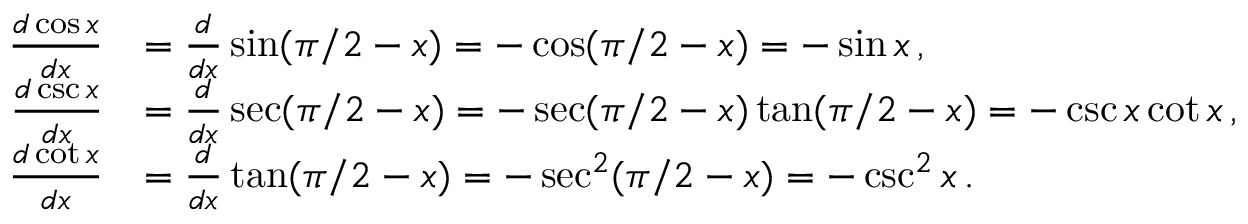<formula> <loc_0><loc_0><loc_500><loc_500>{ \begin{array} { r l } { { \frac { d \cos x } { d x } } } & { = { \frac { d } { d x } } \sin ( \pi / 2 - x ) = - \cos ( \pi / 2 - x ) = - \sin x \, , } \\ { { \frac { d \csc x } { d x } } } & { = { \frac { d } { d x } } \sec ( \pi / 2 - x ) = - \sec ( \pi / 2 - x ) \tan ( \pi / 2 - x ) = - \csc x \cot x \, , } \\ { { \frac { d \cot x } { d x } } } & { = { \frac { d } { d x } } \tan ( \pi / 2 - x ) = - \sec ^ { 2 } ( \pi / 2 - x ) = - \csc ^ { 2 } x \, . } \end{array} }</formula> 